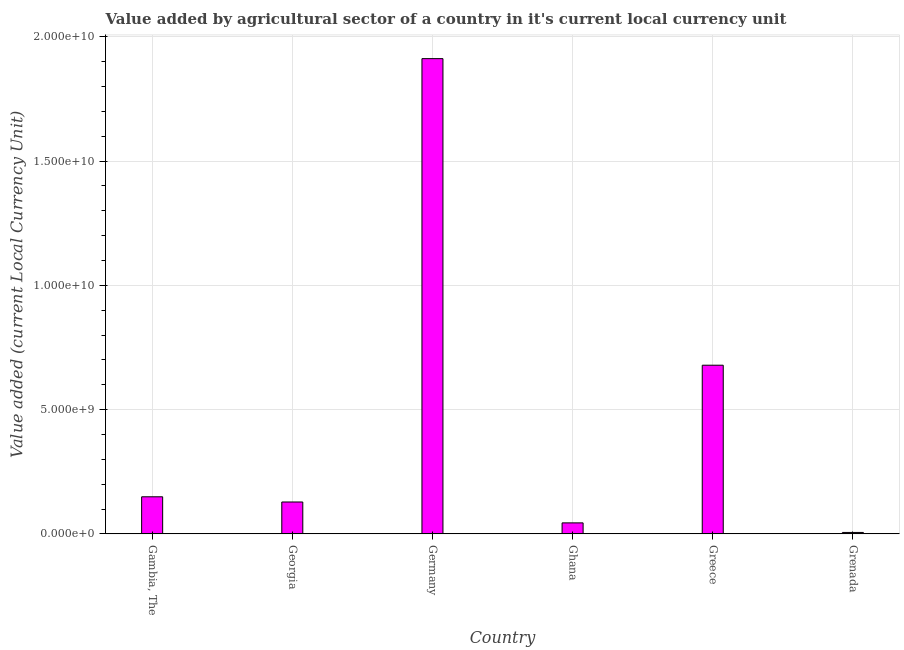Does the graph contain any zero values?
Your response must be concise. No. Does the graph contain grids?
Your answer should be very brief. Yes. What is the title of the graph?
Make the answer very short. Value added by agricultural sector of a country in it's current local currency unit. What is the label or title of the Y-axis?
Provide a short and direct response. Value added (current Local Currency Unit). What is the value added by agriculture sector in Gambia, The?
Your answer should be compact. 1.49e+09. Across all countries, what is the maximum value added by agriculture sector?
Your answer should be very brief. 1.91e+1. Across all countries, what is the minimum value added by agriculture sector?
Your answer should be very brief. 5.72e+07. In which country was the value added by agriculture sector maximum?
Give a very brief answer. Germany. In which country was the value added by agriculture sector minimum?
Offer a very short reply. Grenada. What is the sum of the value added by agriculture sector?
Your response must be concise. 2.92e+1. What is the difference between the value added by agriculture sector in Germany and Grenada?
Give a very brief answer. 1.91e+1. What is the average value added by agriculture sector per country?
Make the answer very short. 4.86e+09. What is the median value added by agriculture sector?
Your response must be concise. 1.39e+09. What is the ratio of the value added by agriculture sector in Germany to that in Ghana?
Offer a very short reply. 43.28. Is the value added by agriculture sector in Gambia, The less than that in Ghana?
Provide a succinct answer. No. Is the difference between the value added by agriculture sector in Germany and Grenada greater than the difference between any two countries?
Offer a terse response. Yes. What is the difference between the highest and the second highest value added by agriculture sector?
Provide a short and direct response. 1.23e+1. What is the difference between the highest and the lowest value added by agriculture sector?
Give a very brief answer. 1.91e+1. How many bars are there?
Offer a terse response. 6. How many countries are there in the graph?
Your answer should be compact. 6. Are the values on the major ticks of Y-axis written in scientific E-notation?
Give a very brief answer. Yes. What is the Value added (current Local Currency Unit) in Gambia, The?
Keep it short and to the point. 1.49e+09. What is the Value added (current Local Currency Unit) in Georgia?
Provide a succinct answer. 1.28e+09. What is the Value added (current Local Currency Unit) of Germany?
Provide a short and direct response. 1.91e+1. What is the Value added (current Local Currency Unit) in Ghana?
Your response must be concise. 4.42e+08. What is the Value added (current Local Currency Unit) in Greece?
Your answer should be compact. 6.78e+09. What is the Value added (current Local Currency Unit) of Grenada?
Offer a terse response. 5.72e+07. What is the difference between the Value added (current Local Currency Unit) in Gambia, The and Georgia?
Offer a terse response. 2.09e+08. What is the difference between the Value added (current Local Currency Unit) in Gambia, The and Germany?
Your answer should be very brief. -1.76e+1. What is the difference between the Value added (current Local Currency Unit) in Gambia, The and Ghana?
Make the answer very short. 1.05e+09. What is the difference between the Value added (current Local Currency Unit) in Gambia, The and Greece?
Your answer should be compact. -5.29e+09. What is the difference between the Value added (current Local Currency Unit) in Gambia, The and Grenada?
Your answer should be compact. 1.43e+09. What is the difference between the Value added (current Local Currency Unit) in Georgia and Germany?
Provide a short and direct response. -1.78e+1. What is the difference between the Value added (current Local Currency Unit) in Georgia and Ghana?
Keep it short and to the point. 8.41e+08. What is the difference between the Value added (current Local Currency Unit) in Georgia and Greece?
Your answer should be very brief. -5.50e+09. What is the difference between the Value added (current Local Currency Unit) in Georgia and Grenada?
Make the answer very short. 1.23e+09. What is the difference between the Value added (current Local Currency Unit) in Germany and Ghana?
Make the answer very short. 1.87e+1. What is the difference between the Value added (current Local Currency Unit) in Germany and Greece?
Your answer should be very brief. 1.23e+1. What is the difference between the Value added (current Local Currency Unit) in Germany and Grenada?
Keep it short and to the point. 1.91e+1. What is the difference between the Value added (current Local Currency Unit) in Ghana and Greece?
Provide a short and direct response. -6.34e+09. What is the difference between the Value added (current Local Currency Unit) in Ghana and Grenada?
Keep it short and to the point. 3.84e+08. What is the difference between the Value added (current Local Currency Unit) in Greece and Grenada?
Make the answer very short. 6.73e+09. What is the ratio of the Value added (current Local Currency Unit) in Gambia, The to that in Georgia?
Your answer should be compact. 1.16. What is the ratio of the Value added (current Local Currency Unit) in Gambia, The to that in Germany?
Keep it short and to the point. 0.08. What is the ratio of the Value added (current Local Currency Unit) in Gambia, The to that in Ghana?
Make the answer very short. 3.38. What is the ratio of the Value added (current Local Currency Unit) in Gambia, The to that in Greece?
Ensure brevity in your answer.  0.22. What is the ratio of the Value added (current Local Currency Unit) in Gambia, The to that in Grenada?
Offer a terse response. 26.06. What is the ratio of the Value added (current Local Currency Unit) in Georgia to that in Germany?
Offer a terse response. 0.07. What is the ratio of the Value added (current Local Currency Unit) in Georgia to that in Ghana?
Provide a succinct answer. 2.9. What is the ratio of the Value added (current Local Currency Unit) in Georgia to that in Greece?
Your answer should be compact. 0.19. What is the ratio of the Value added (current Local Currency Unit) in Georgia to that in Grenada?
Keep it short and to the point. 22.41. What is the ratio of the Value added (current Local Currency Unit) in Germany to that in Ghana?
Offer a terse response. 43.28. What is the ratio of the Value added (current Local Currency Unit) in Germany to that in Greece?
Provide a succinct answer. 2.82. What is the ratio of the Value added (current Local Currency Unit) in Germany to that in Grenada?
Provide a succinct answer. 334.13. What is the ratio of the Value added (current Local Currency Unit) in Ghana to that in Greece?
Provide a short and direct response. 0.07. What is the ratio of the Value added (current Local Currency Unit) in Ghana to that in Grenada?
Provide a succinct answer. 7.72. What is the ratio of the Value added (current Local Currency Unit) in Greece to that in Grenada?
Offer a very short reply. 118.58. 